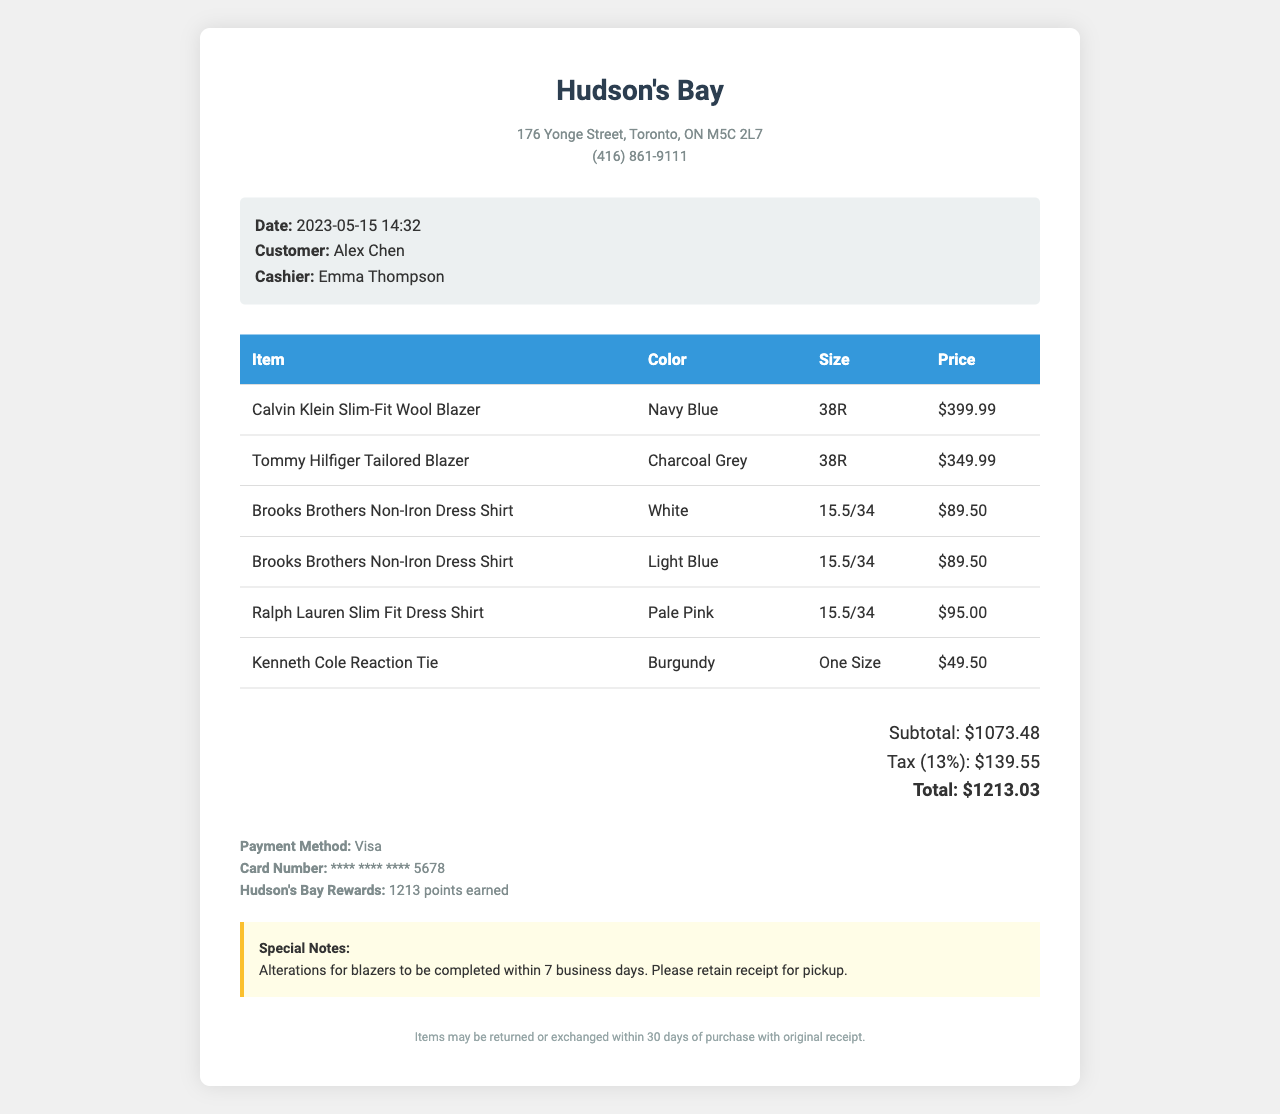What is the store name? The store name is prominently displayed at the top of the receipt.
Answer: Hudson's Bay What is the total amount? The total amount is calculated as the subtotal plus tax, which is listed near the bottom of the receipt.
Answer: 1213.03 What color is the Calvin Klein blazer? The color of each item is clearly indicated in the items table next to each item name.
Answer: Navy Blue What size is the Ralph Lauren dress shirt? Size information is provided in the items table for each clothing item.
Answer: 15.5/34 Who was the cashier? The cashier's name is mentioned along with the date and time of the purchase.
Answer: Emma Thompson How many points were earned from this purchase? The points earned are displayed in the payment information section of the receipt.
Answer: 1213 What is the return policy period? The return policy is specified in the footer section of the receipt, providing details about returns.
Answer: 30 days What special note is mentioned regarding the blazers? Special notes regarding the items purchased are provided in a designated section of the receipt.
Answer: Alterations for blazers to be completed within 7 business days What are the colors of the Brooks Brothers Non-Iron Dress Shirts? Multiple items are listed in the items table, including their respective colors, which can be directly compared.
Answer: White and Light Blue What payment method was used? The payment method is clearly indicated in the payment section of the receipt.
Answer: Visa 